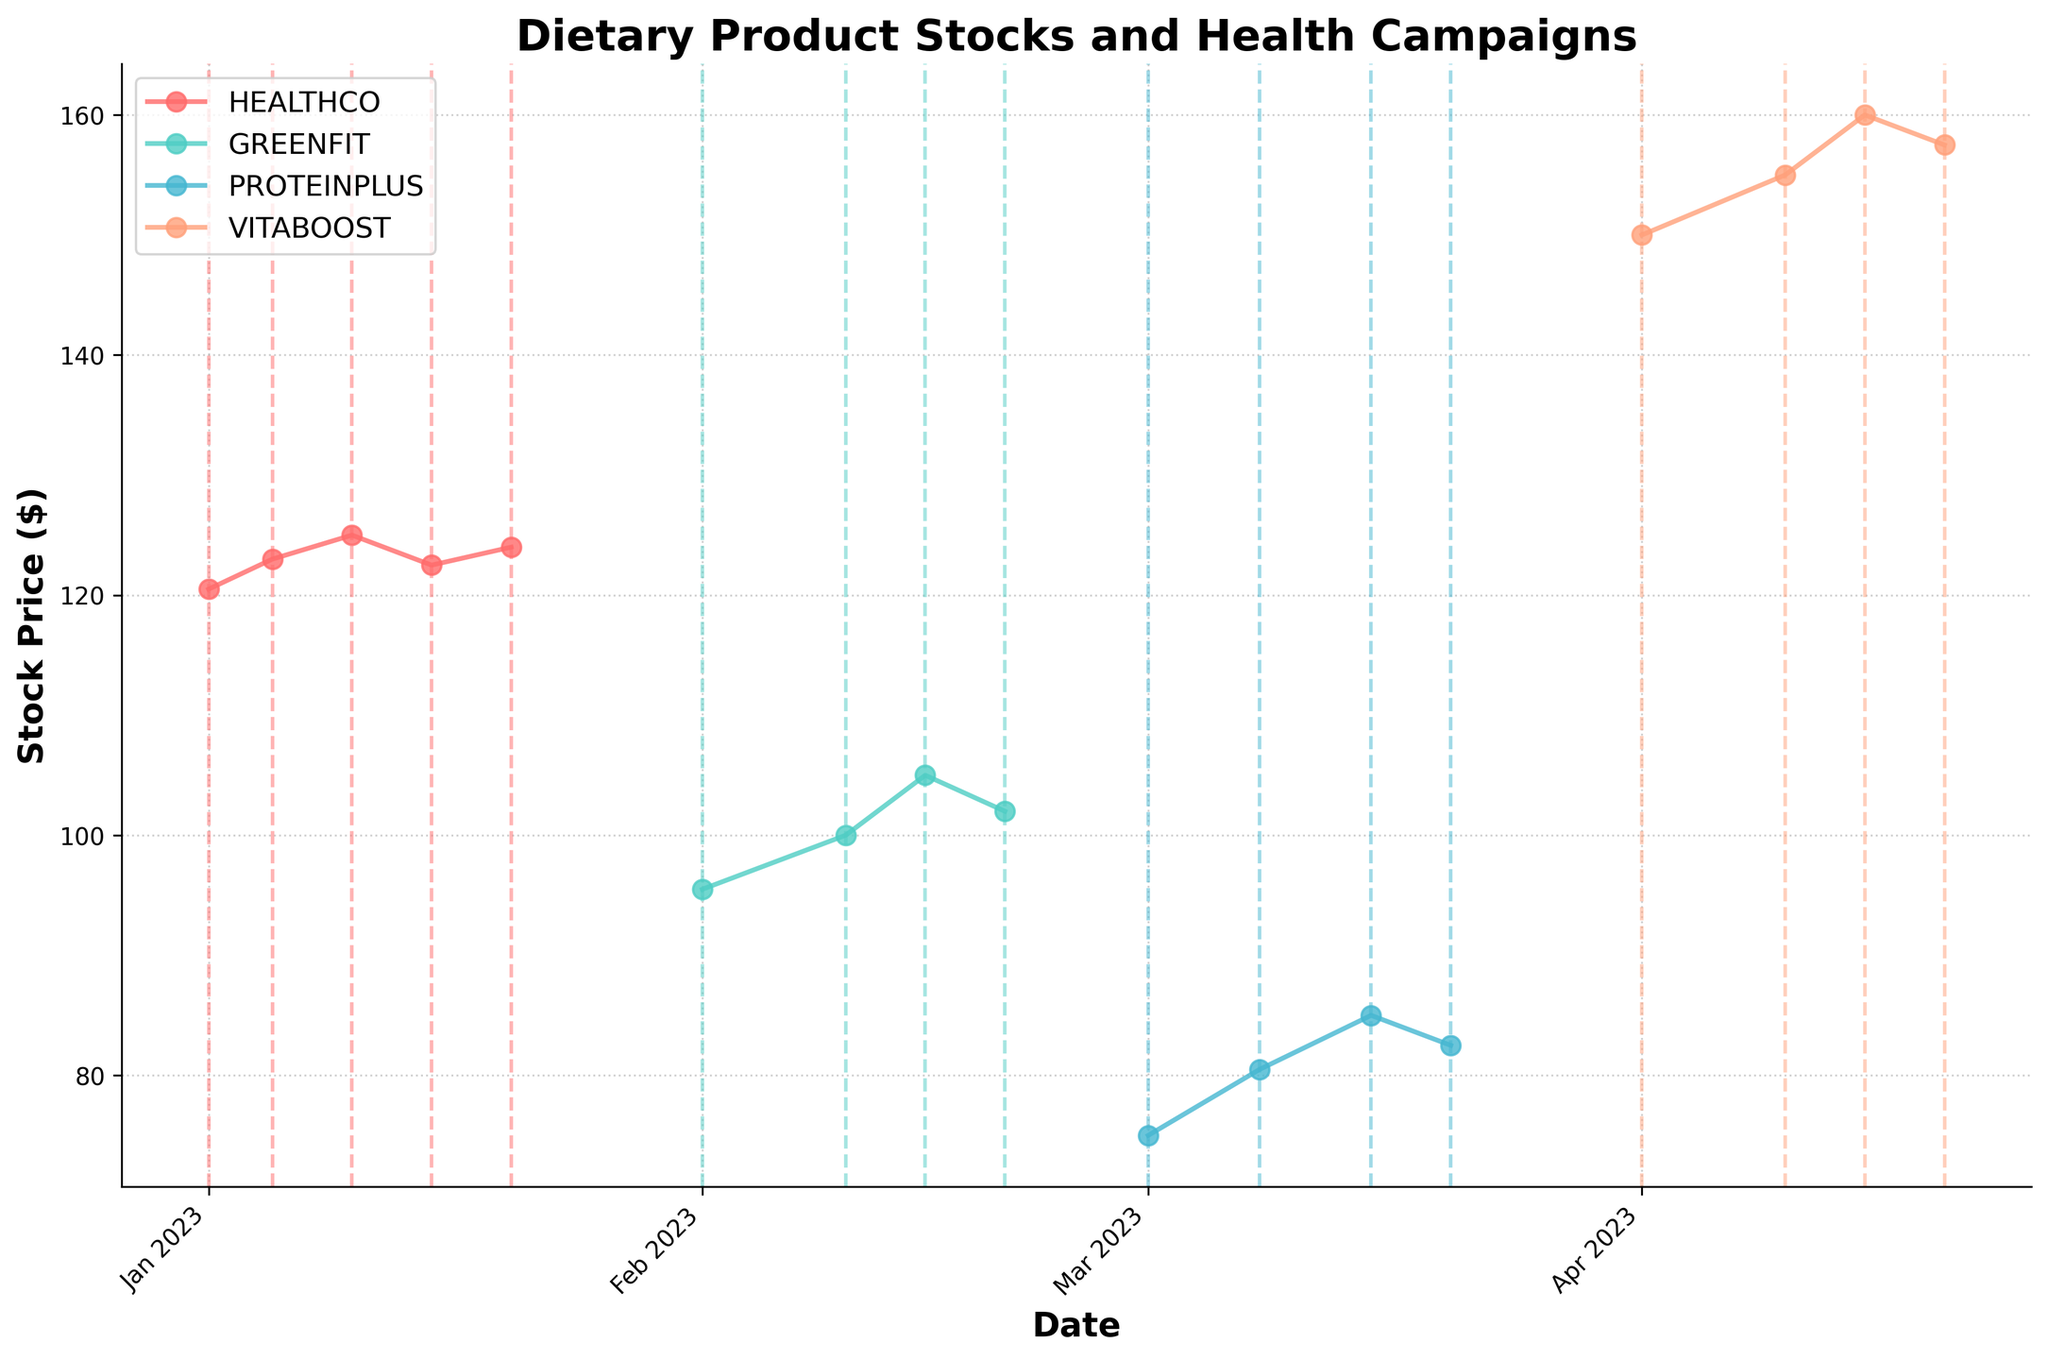What is the title of the figure? The title of the figure can be found at the top of the plot. It summarizes the key point of the visual representation.
Answer: Dietary Product Stocks and Health Campaigns Which company has the highest stock price in the figure? To answer, look at the peaks of the plotted lines for all companies. The company with the highest value is the one with the highest peak.
Answer: VITABOOST How many health campaigns are shown in total? Count the number of distinct vertical dashed lines, representing health campaigns, corresponding to different dates.
Answer: 4 What is the stock price of GREENFIT on February 15, 2023? Find the data point for GREENFIT at the date February 15, 2023 by following its line and noting the value on the y-axis.
Answer: 105.0 Which company shows the largest price increase during a health campaign? Examine the stock price difference before and during each health campaign for each company. The company with the largest positive change has the largest increase.
Answer: PROTEINPLUS During which campaign did HEALTHCO see an increase in stock price? Identify the health campaigns associated with HEALTHCO by looking at vertical dashed lines and comparing stock prices before and during these periods.
Answer: New Year Health Campaign Compare the stock prices of HEALTHCO and GREENFIT on January 15, 2023, and February 15, 2023, respectively. Which one is higher? Locate the stock prices of HEALTHCO on January 15 and GREENFIT on February 15 along their respective lines and compare the values.
Answer: GREENFIT (105.0 > 122.5) What is the average stock price of PROTEINPLUS during the National Nutrition Month campaign? Find the stock prices of PROTEINPLUS during the campaign and calculate the mean. The values are 80.5 and 85.0.
Answer: (80.5 + 85.0)/2 = 82.75 Did any company's stock price decrease immediately after a health campaign? If so, which one(s)? Check the stock prices of companies immediately after the health campaign concludes, indicated by the next data point. Look for a decrease from the campaign period.
Answer: All companies except HEALTHCO 